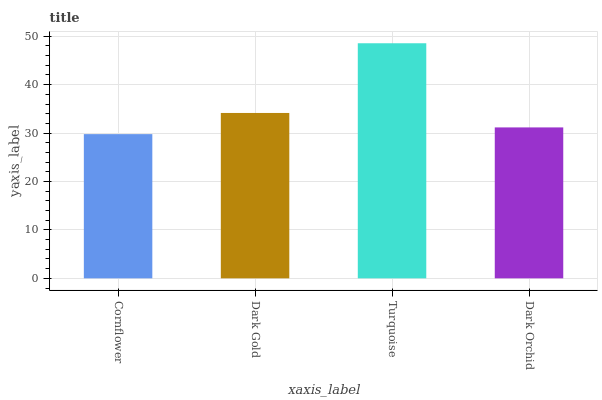Is Cornflower the minimum?
Answer yes or no. Yes. Is Turquoise the maximum?
Answer yes or no. Yes. Is Dark Gold the minimum?
Answer yes or no. No. Is Dark Gold the maximum?
Answer yes or no. No. Is Dark Gold greater than Cornflower?
Answer yes or no. Yes. Is Cornflower less than Dark Gold?
Answer yes or no. Yes. Is Cornflower greater than Dark Gold?
Answer yes or no. No. Is Dark Gold less than Cornflower?
Answer yes or no. No. Is Dark Gold the high median?
Answer yes or no. Yes. Is Dark Orchid the low median?
Answer yes or no. Yes. Is Turquoise the high median?
Answer yes or no. No. Is Dark Gold the low median?
Answer yes or no. No. 